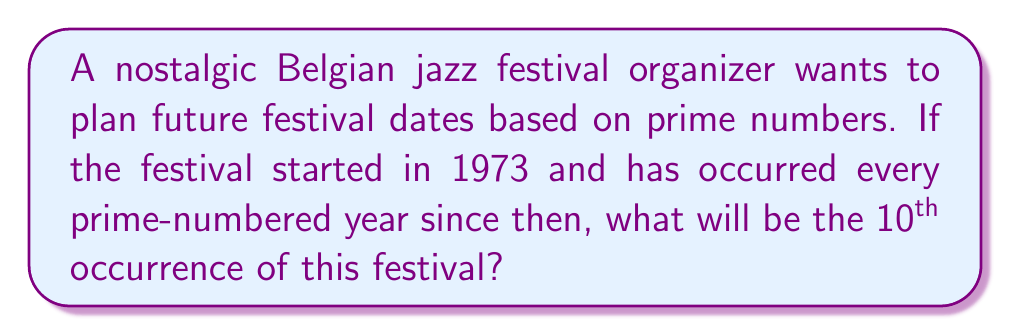Solve this math problem. Let's approach this step-by-step:

1) First, we need to list the prime numbers starting from 1973:
   1973, 1979, 1987, 1993, 1997, 1999, 2003, 2011, 2017, 2027

2) We can verify these are prime using the following method:
   - Check if each number is divisible by any integer from 2 up to its square root.
   - If it's not divisible by any of these numbers, it's prime.

3) Now, let's count the years when the festival occurred:
   1st: 1973
   2nd: 1979
   3rd: 1987
   4th: 1993
   5th: 1997
   6th: 1999
   7th: 2003
   8th: 2011
   9th: 2017
   10th: 2027

4) Therefore, the 10th occurrence of the festival will be in 2027.

5) We can express this mathematically as:

   $$f(n) = p_n$$

   Where $f(n)$ is the year of the nth festival, and $p_n$ is the nth prime number greater than or equal to 1973.

   In this case, we're looking for $f(10)$, which equals $p_{10} = 2027$.
Answer: 2027 